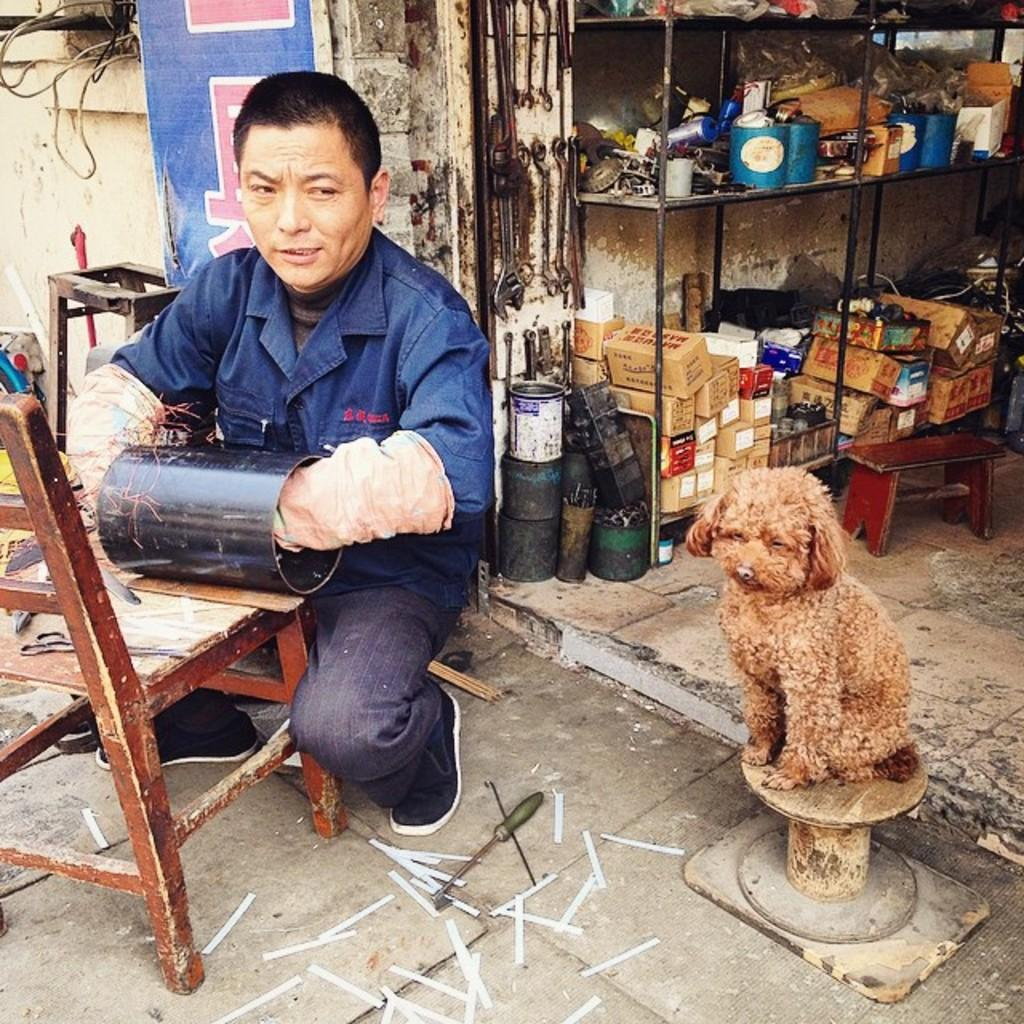What is the person in the image doing? The person is sitting in the image. What is the person holding in their hands? The person is holding an object in their hands. What is the person sitting on in the image? There is a chair in the image, which the person is likely sitting on. What other living creature is present in the image? There is a dog in the image. What can be seen in the background of the image? There are objects visible in the background of the image. What type of quartz can be seen in the vein of the person in the image? There is no quartz or vein visible in the image; it features a person sitting and holding an object, a dog, and objects in the background. 